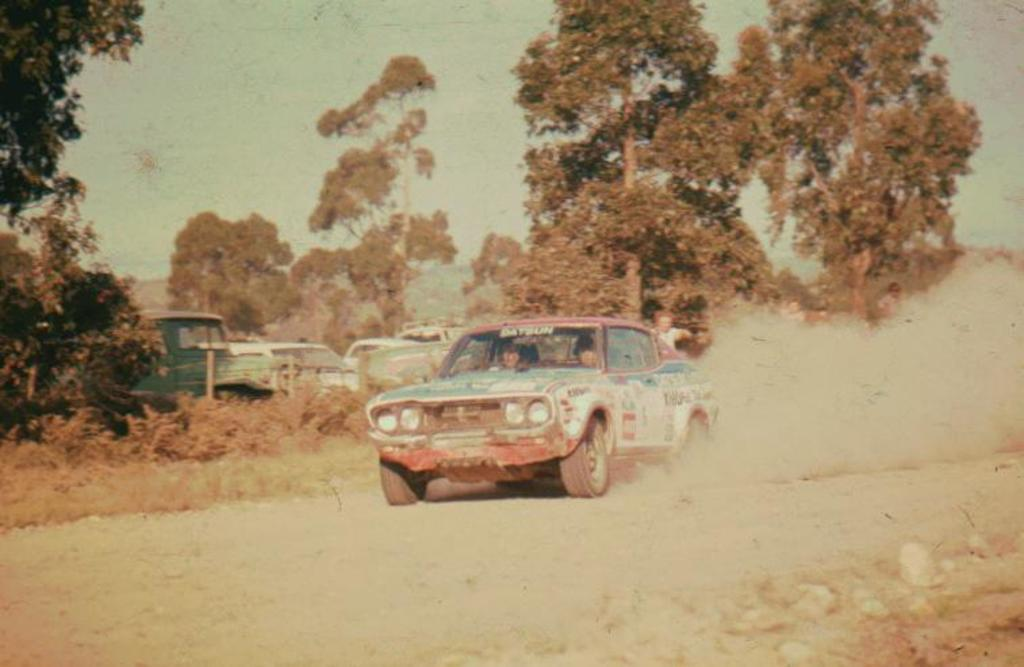What is the main subject of the image? The main subject of the image is a car. Are there any people inside the car? Yes, there are two persons inside the car. What can be seen in the background of the image? There are trees, at least one other vehicle, and the sky visible in the background of the image. What type of bell can be heard ringing in the image? There is no bell present or ringing in the image. Can you see any squirrels climbing the trees in the background of the image? There is no mention of squirrels in the image, only trees and other vehicles. 